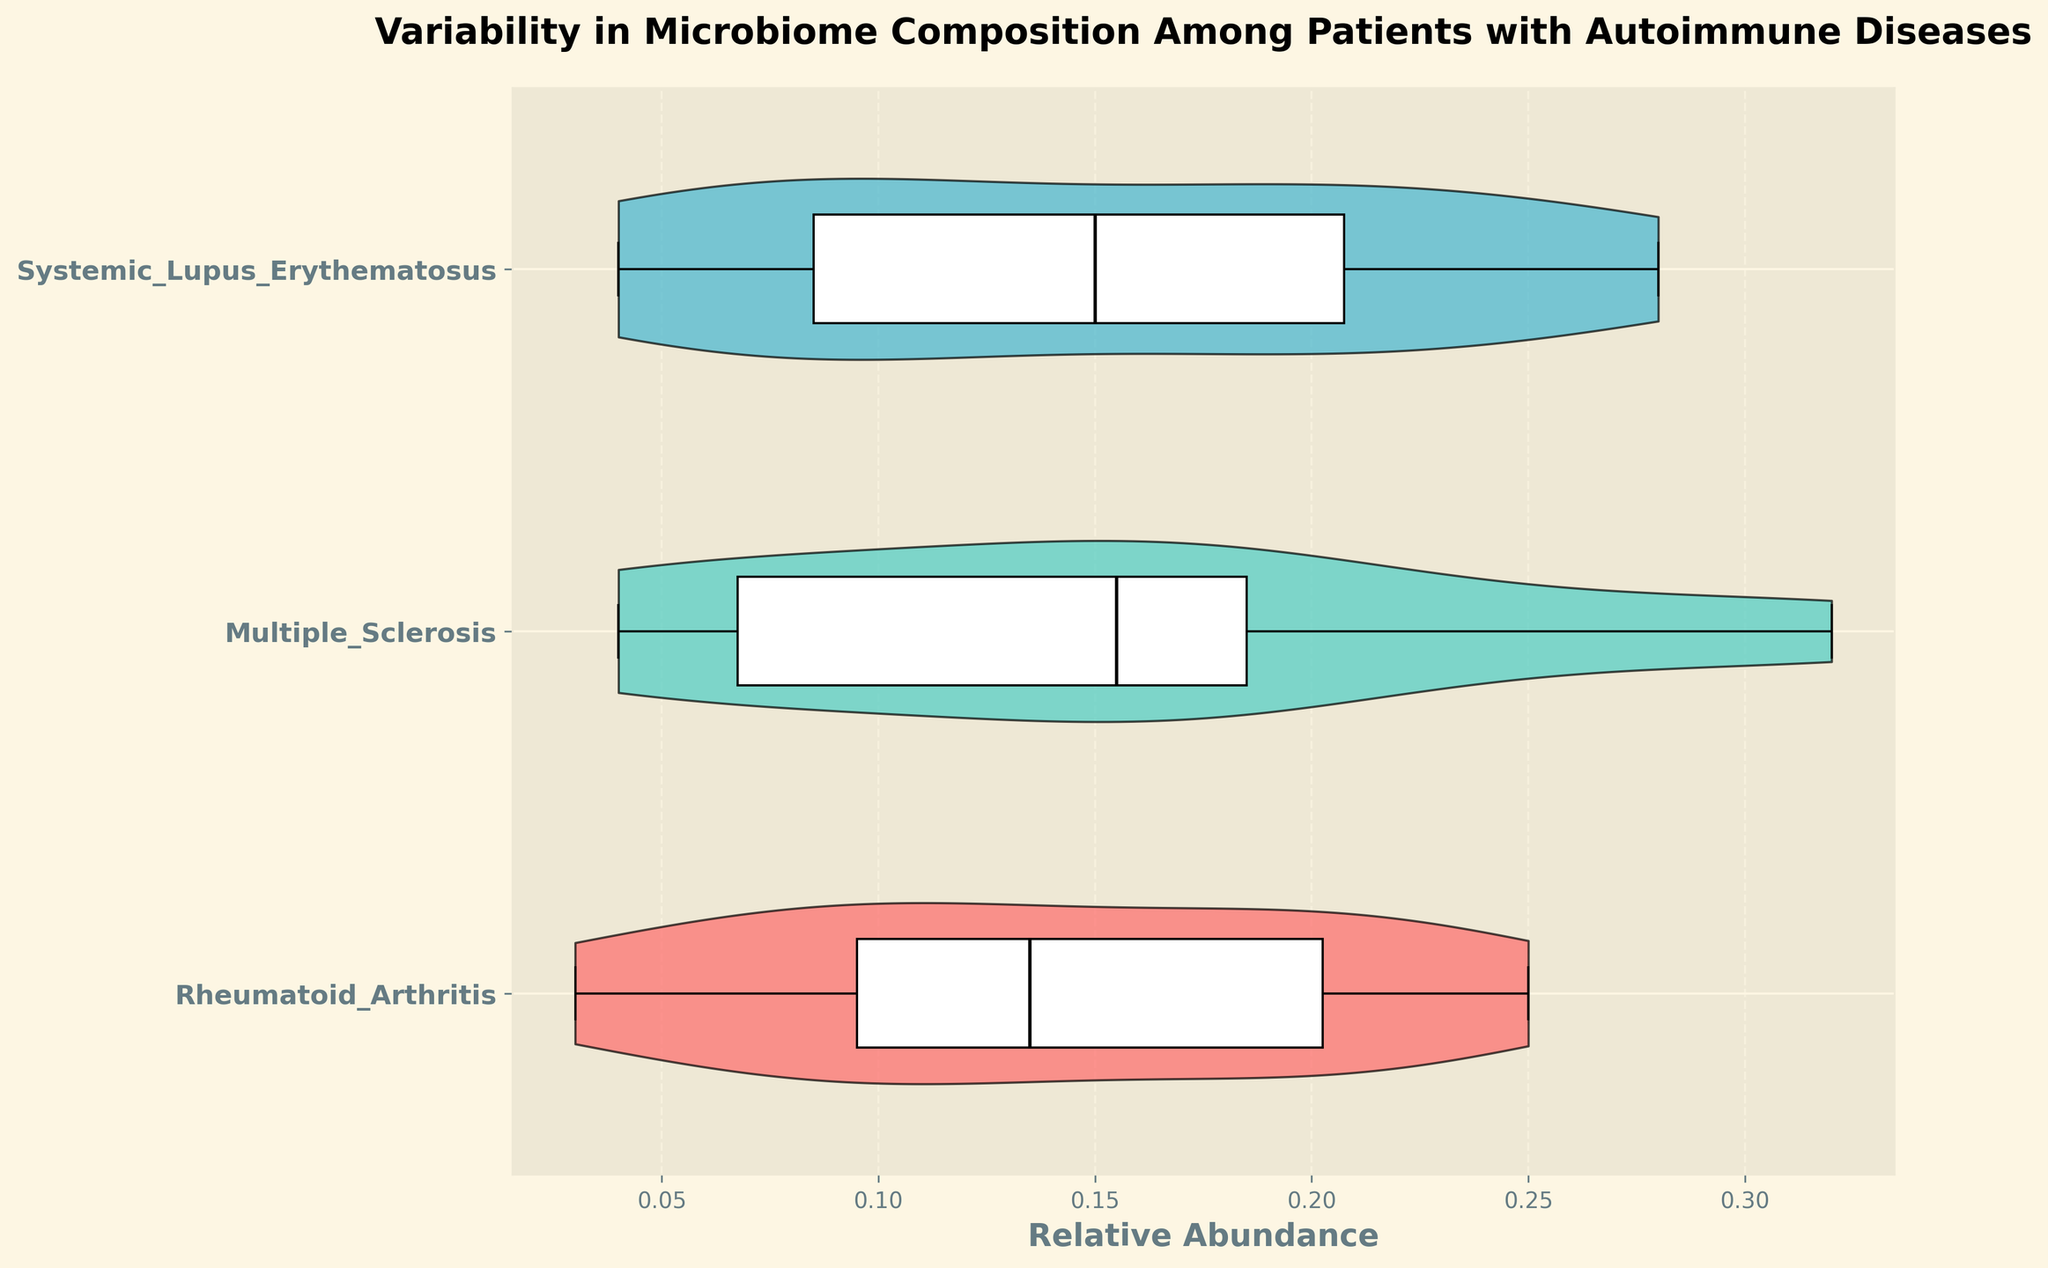what is the title of the figure? The title is located at the top of the figure and provides a brief description of what the figure represents.
Answer: Variability in Microbiome Composition Among Patients with Autoimmune Diseases which disease type uses the color '#45B7D1'? The figure's legend or color coding indicates that the color '#45B7D1' corresponds to a specific disease type.
Answer: Systemic Lupus Erythematosus how many groups are compared in the violin plot? By looking at the y-axis labels, which represent different groups being compared, you can count the number of unique groups.
Answer: 3 what is the x-axis label? The label for the x-axis is typically located beneath the x-axis and indicates what the horizontal axis represents.
Answer: Relative Abundance which disease type appears to have the highest variability in microbiome composition? By examining the width of the violin plots, which represents the distribution and variability of data, you can identify which group has the widest plot.
Answer: Systemic Lupus Erythematosus how do the median relative abundance values of Rheumatoid Arthritis and Multiple Sclerosis compare? The black line within each violin plot represents the median, and by comparing the median lines of these two groups, you can see which is higher.
Answer: Rheumatoid Arthritis has a higher median relative abundance which disease type exhibits the lowest median abundance in microbiome composition? By examining the black median lines within the violin plots, you can identify which disease type has the lowest position for its median line.
Answer: Multiple Sclerosis what is the main difference between the violin plot and a traditional box plot? A violin plot not only shows the summary statistics of the data like a box plot but also includes a kernel density estimation to reveal the distribution shape, whereas a box plot does not.
Answer: Violin plot shows data distribution are there any disease types with overlapping distributions of microbiome composition? By observing the areas where the shapes of the different violin plots overlap, you can determine if any groups have overlapping distributions.
Answer: Yes, some overlaps exist what can you infer from the fact that the box inside the violin is white? The white box indicates that a box plot is overlaid within the violin plot; the white color allows the box plot to stand out without obscuring the data distribution.
Answer: Box plot overlay inside the violin plot 